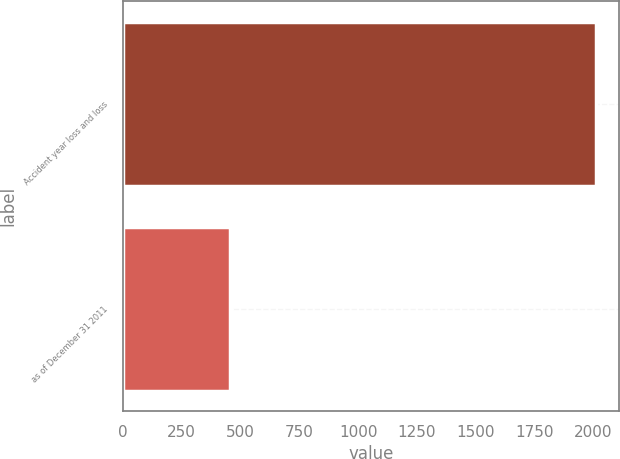Convert chart. <chart><loc_0><loc_0><loc_500><loc_500><bar_chart><fcel>Accident year loss and loss<fcel>as of December 31 2011<nl><fcel>2011<fcel>455<nl></chart> 